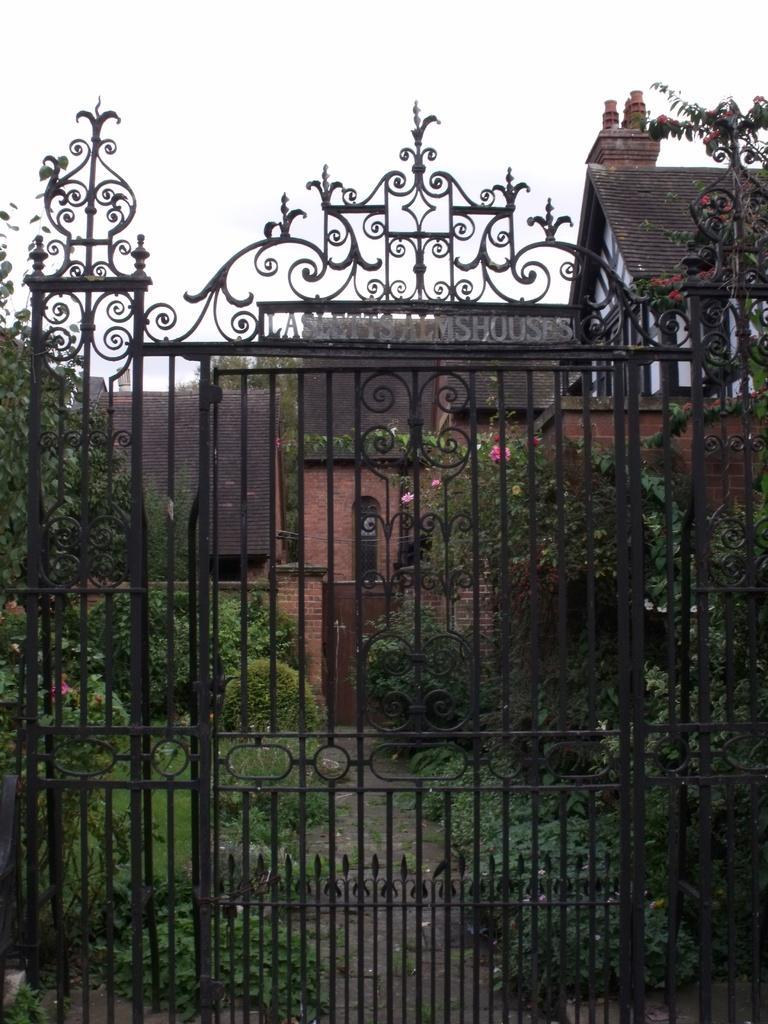Describe this image in one or two sentences. In this picture I can observe a black color gate. Behind the gate there are some plants on the land. In the background there is a building and a sky. 